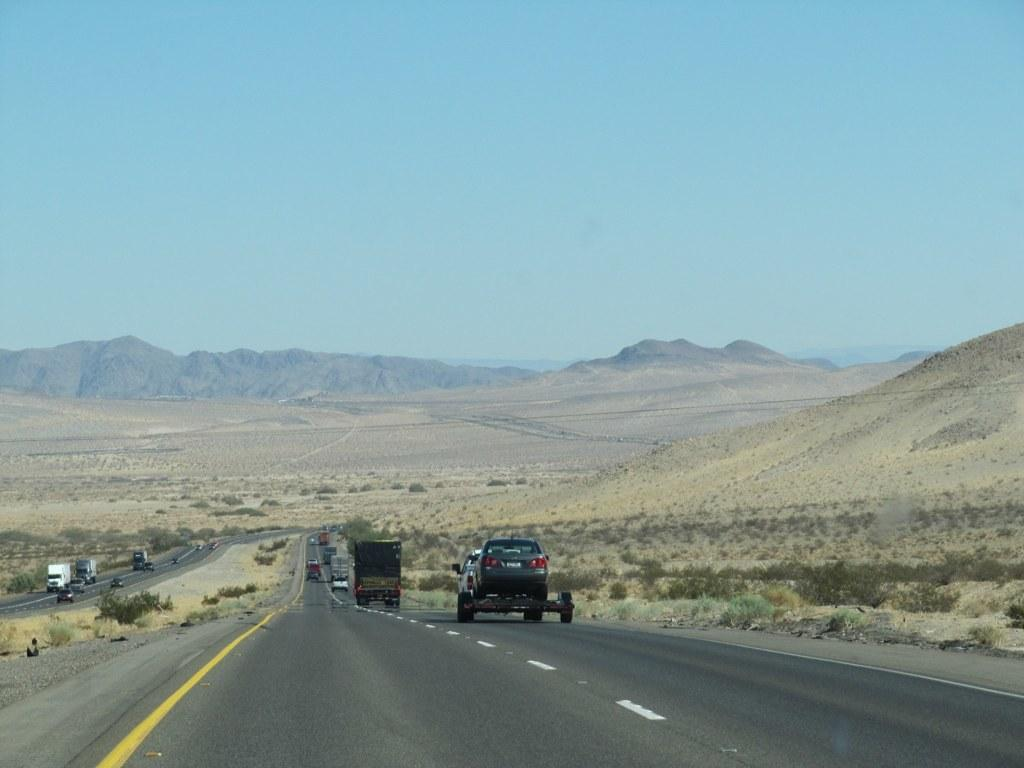What is happening on the roads in the image? There are vehicles moving on the roads in the image. What type of vegetation can be seen in the image? There are plants visible in the image. What natural feature is present in the image? There are mountains in the image. What is visible in the background of the image? The sky is visible in the background of the image. How many legs can be seen on the mountains in the image? Mountains do not have legs; they are a natural geological formation. What type of profit can be gained from the plants in the image? The image does not provide information about the potential profit from the plants, nor does it suggest that the plants are being used for commercial purposes. 